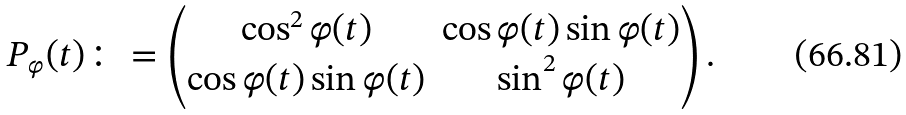<formula> <loc_0><loc_0><loc_500><loc_500>P _ { \varphi } ( t ) \colon = \begin{pmatrix} \cos ^ { 2 } \varphi ( t ) & \cos \varphi ( t ) \sin \varphi ( t ) \\ \cos \varphi ( t ) \sin \varphi ( t ) & \sin ^ { 2 } \varphi ( t ) \end{pmatrix} .</formula> 